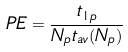Convert formula to latex. <formula><loc_0><loc_0><loc_500><loc_500>P E = \frac { t _ { 1 p } } { N _ { p } t _ { a v } ( N _ { p } ) }</formula> 